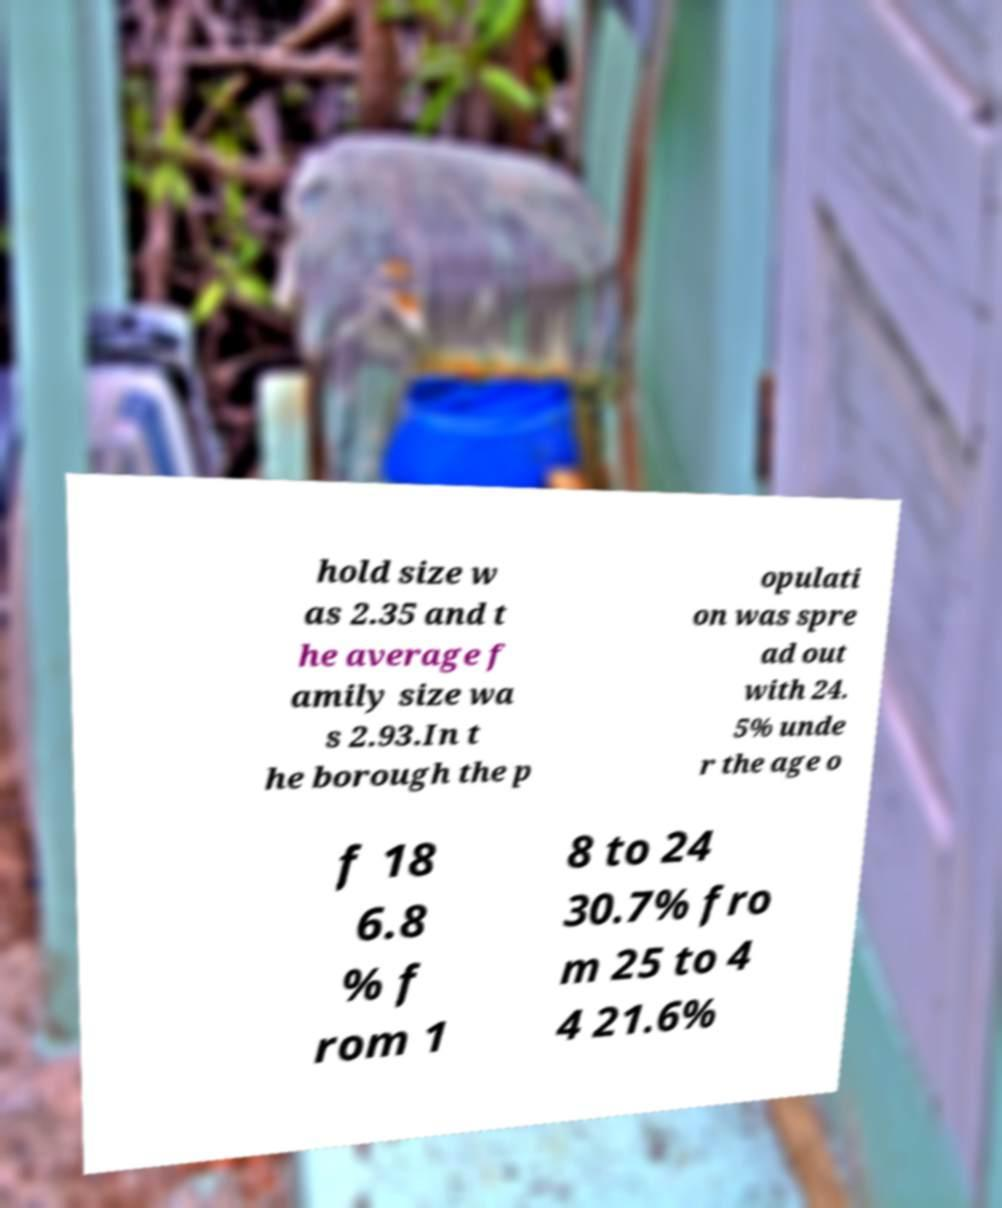Can you accurately transcribe the text from the provided image for me? hold size w as 2.35 and t he average f amily size wa s 2.93.In t he borough the p opulati on was spre ad out with 24. 5% unde r the age o f 18 6.8 % f rom 1 8 to 24 30.7% fro m 25 to 4 4 21.6% 